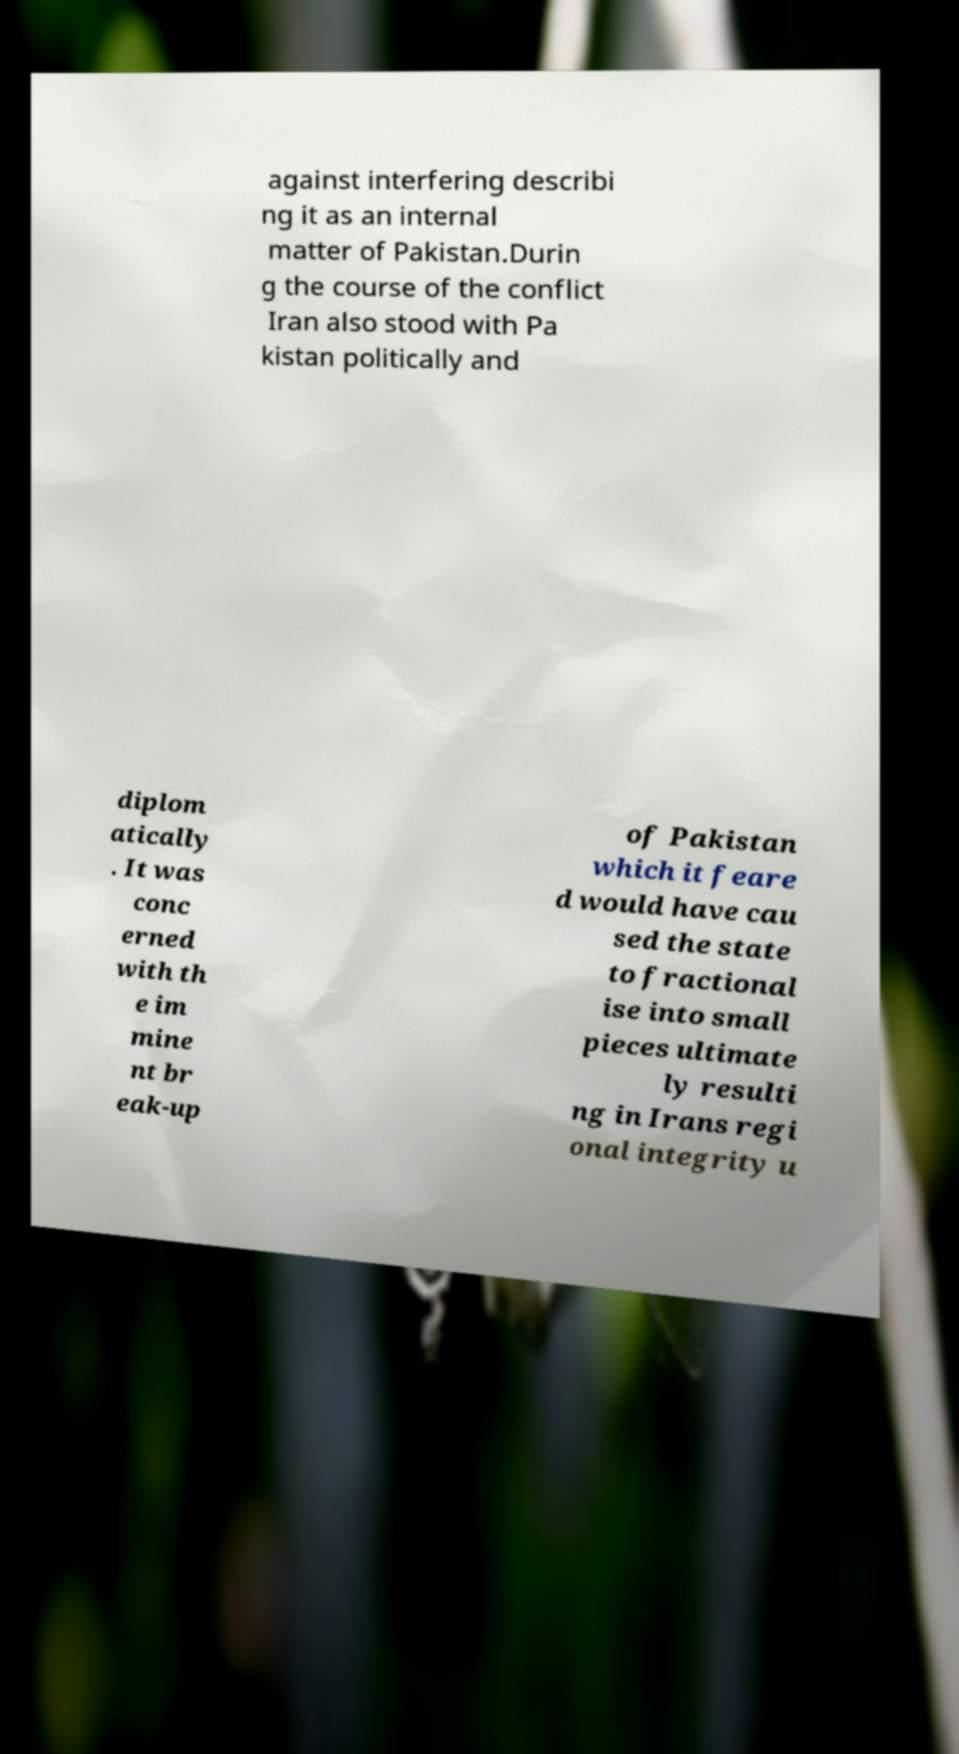What messages or text are displayed in this image? I need them in a readable, typed format. against interfering describi ng it as an internal matter of Pakistan.Durin g the course of the conflict Iran also stood with Pa kistan politically and diplom atically . It was conc erned with th e im mine nt br eak-up of Pakistan which it feare d would have cau sed the state to fractional ise into small pieces ultimate ly resulti ng in Irans regi onal integrity u 